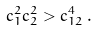<formula> <loc_0><loc_0><loc_500><loc_500>c _ { 1 } ^ { 2 } c _ { 2 } ^ { 2 } > c _ { 1 2 } ^ { 4 } \, .</formula> 